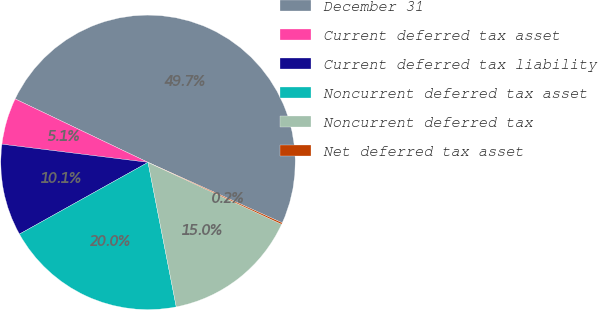<chart> <loc_0><loc_0><loc_500><loc_500><pie_chart><fcel>December 31<fcel>Current deferred tax asset<fcel>Current deferred tax liability<fcel>Noncurrent deferred tax asset<fcel>Noncurrent deferred tax<fcel>Net deferred tax asset<nl><fcel>49.65%<fcel>5.12%<fcel>10.07%<fcel>19.97%<fcel>15.02%<fcel>0.17%<nl></chart> 